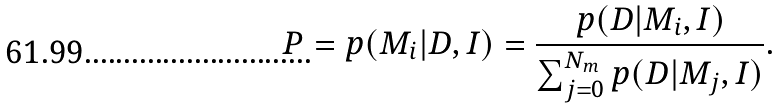Convert formula to latex. <formula><loc_0><loc_0><loc_500><loc_500>P = p ( M _ { i } | D , I ) = \frac { p ( D | M _ { i } , I ) } { \sum _ { j = 0 } ^ { N _ { m } } p ( D | M _ { j } , I ) } .</formula> 